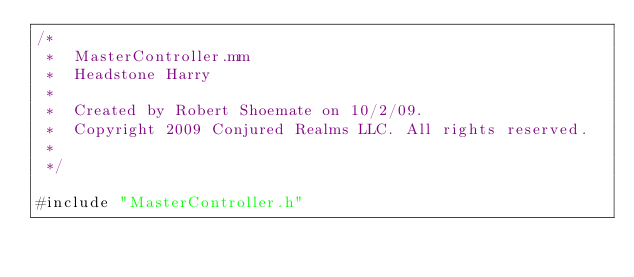Convert code to text. <code><loc_0><loc_0><loc_500><loc_500><_ObjectiveC_>/*
 *  MasterController.mm
 *  Headstone Harry
 *
 *  Created by Robert Shoemate on 10/2/09.
 *  Copyright 2009 Conjured Realms LLC. All rights reserved.
 *
 */

#include "MasterController.h"

</code> 